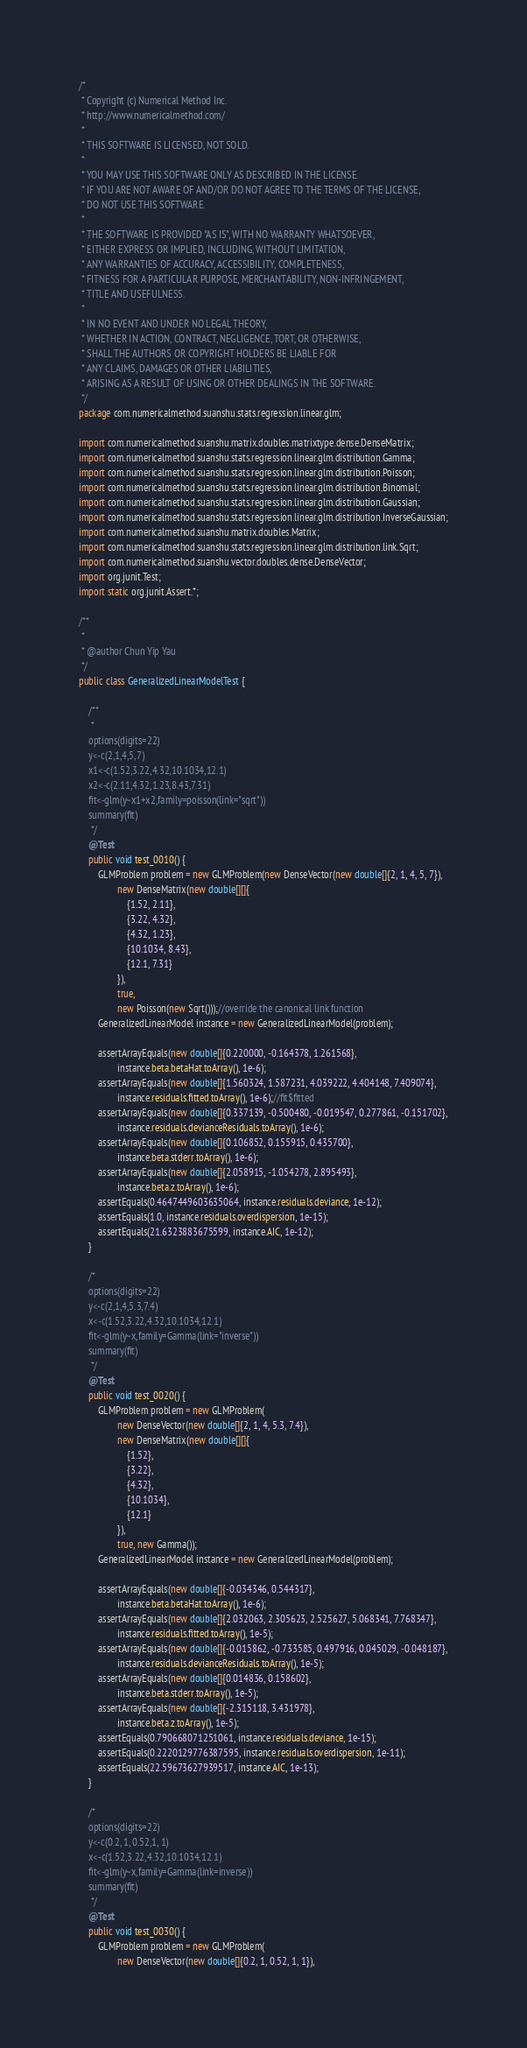<code> <loc_0><loc_0><loc_500><loc_500><_Java_>/*
 * Copyright (c) Numerical Method Inc.
 * http://www.numericalmethod.com/
 *
 * THIS SOFTWARE IS LICENSED, NOT SOLD.
 *
 * YOU MAY USE THIS SOFTWARE ONLY AS DESCRIBED IN THE LICENSE.
 * IF YOU ARE NOT AWARE OF AND/OR DO NOT AGREE TO THE TERMS OF THE LICENSE,
 * DO NOT USE THIS SOFTWARE.
 *
 * THE SOFTWARE IS PROVIDED "AS IS", WITH NO WARRANTY WHATSOEVER,
 * EITHER EXPRESS OR IMPLIED, INCLUDING, WITHOUT LIMITATION,
 * ANY WARRANTIES OF ACCURACY, ACCESSIBILITY, COMPLETENESS,
 * FITNESS FOR A PARTICULAR PURPOSE, MERCHANTABILITY, NON-INFRINGEMENT,
 * TITLE AND USEFULNESS.
 *
 * IN NO EVENT AND UNDER NO LEGAL THEORY,
 * WHETHER IN ACTION, CONTRACT, NEGLIGENCE, TORT, OR OTHERWISE,
 * SHALL THE AUTHORS OR COPYRIGHT HOLDERS BE LIABLE FOR
 * ANY CLAIMS, DAMAGES OR OTHER LIABILITIES,
 * ARISING AS A RESULT OF USING OR OTHER DEALINGS IN THE SOFTWARE.
 */
package com.numericalmethod.suanshu.stats.regression.linear.glm;

import com.numericalmethod.suanshu.matrix.doubles.matrixtype.dense.DenseMatrix;
import com.numericalmethod.suanshu.stats.regression.linear.glm.distribution.Gamma;
import com.numericalmethod.suanshu.stats.regression.linear.glm.distribution.Poisson;
import com.numericalmethod.suanshu.stats.regression.linear.glm.distribution.Binomial;
import com.numericalmethod.suanshu.stats.regression.linear.glm.distribution.Gaussian;
import com.numericalmethod.suanshu.stats.regression.linear.glm.distribution.InverseGaussian;
import com.numericalmethod.suanshu.matrix.doubles.Matrix;
import com.numericalmethod.suanshu.stats.regression.linear.glm.distribution.link.Sqrt;
import com.numericalmethod.suanshu.vector.doubles.dense.DenseVector;
import org.junit.Test;
import static org.junit.Assert.*;

/**
 *
 * @author Chun Yip Yau
 */
public class GeneralizedLinearModelTest {

    /**
     *
    options(digits=22)
    y<-c(2,1,4,5,7)
    x1<-c(1.52,3.22,4.32,10.1034,12.1)
    x2<-c(2.11,4.32,1.23,8.43,7.31)
    fit<-glm(y~x1+x2,family=poisson(link="sqrt"))
    summary(fit)
     */
    @Test
    public void test_0010() {
        GLMProblem problem = new GLMProblem(new DenseVector(new double[]{2, 1, 4, 5, 7}),
                new DenseMatrix(new double[][]{
                    {1.52, 2.11},
                    {3.22, 4.32},
                    {4.32, 1.23},
                    {10.1034, 8.43},
                    {12.1, 7.31}
                }),
                true,
                new Poisson(new Sqrt()));//override the canonical link function
        GeneralizedLinearModel instance = new GeneralizedLinearModel(problem);

        assertArrayEquals(new double[]{0.220000, -0.164378, 1.261568},
                instance.beta.betaHat.toArray(), 1e-6);
        assertArrayEquals(new double[]{1.560324, 1.587231, 4.039222, 4.404148, 7.409074},
                instance.residuals.fitted.toArray(), 1e-6);//fit$fitted
        assertArrayEquals(new double[]{0.337139, -0.500480, -0.019547, 0.277861, -0.151702},
                instance.residuals.devianceResiduals.toArray(), 1e-6);
        assertArrayEquals(new double[]{0.106852, 0.155915, 0.435700},
                instance.beta.stderr.toArray(), 1e-6);
        assertArrayEquals(new double[]{2.058915, -1.054278, 2.895493},
                instance.beta.z.toArray(), 1e-6);
        assertEquals(0.4647449603635064, instance.residuals.deviance, 1e-12);
        assertEquals(1.0, instance.residuals.overdispersion, 1e-15);
        assertEquals(21.6323883675599, instance.AIC, 1e-12);
    }

    /*
    options(digits=22)
    y<-c(2,1,4,5.3,7.4)
    x<-c(1.52,3.22,4.32,10.1034,12.1)
    fit<-glm(y~x,family=Gamma(link="inverse"))
    summary(fit)
     */
    @Test
    public void test_0020() {
        GLMProblem problem = new GLMProblem(
                new DenseVector(new double[]{2, 1, 4, 5.3, 7.4}),
                new DenseMatrix(new double[][]{
                    {1.52},
                    {3.22},
                    {4.32},
                    {10.1034},
                    {12.1}
                }),
                true, new Gamma());
        GeneralizedLinearModel instance = new GeneralizedLinearModel(problem);

        assertArrayEquals(new double[]{-0.034346, 0.544317},
                instance.beta.betaHat.toArray(), 1e-6);
        assertArrayEquals(new double[]{2.032063, 2.305623, 2.525627, 5.068341, 7.768347},
                instance.residuals.fitted.toArray(), 1e-5);
        assertArrayEquals(new double[]{-0.015862, -0.733585, 0.497916, 0.045029, -0.048187},
                instance.residuals.devianceResiduals.toArray(), 1e-5);
        assertArrayEquals(new double[]{0.014836, 0.158602},
                instance.beta.stderr.toArray(), 1e-5);
        assertArrayEquals(new double[]{-2.315118, 3.431978},
                instance.beta.z.toArray(), 1e-5);
        assertEquals(0.790668071251061, instance.residuals.deviance, 1e-15);
        assertEquals(0.2220129776387595, instance.residuals.overdispersion, 1e-11);
        assertEquals(22.59673627939517, instance.AIC, 1e-13);
    }

    /*
    options(digits=22)
    y<-c(0.2, 1, 0.52,1, 1)
    x<-c(1.52,3.22,4.32,10.1034,12.1)
    fit<-glm(y~x,family=Gamma(link=inverse))
    summary(fit)
     */
    @Test
    public void test_0030() {
        GLMProblem problem = new GLMProblem(
                new DenseVector(new double[]{0.2, 1, 0.52, 1, 1}),</code> 